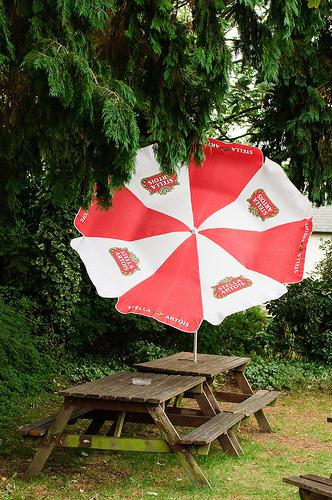Question: what color are the tables?
Choices:
A. White.
B. Green.
C. Brown.
D. Black.
Answer with the letter. Answer: C Question: where is the Umbrella?
Choices:
A. On hook.
B. Floor.
C. Over table.
D. In purse.
Answer with the letter. Answer: C Question: what type of tables are shown?
Choices:
A. Picnic.
B. Dining.
C. Kitchen.
D. Coffee.
Answer with the letter. Answer: A Question: what are the tables made of?
Choices:
A. Glass.
B. Solid oak.
C. Wood.
D. Metal.
Answer with the letter. Answer: C Question: what does the umbrella say?
Choices:
A. Shed rain.
B. Gripz.
C. Leighton.
D. Stella Artois.
Answer with the letter. Answer: D 